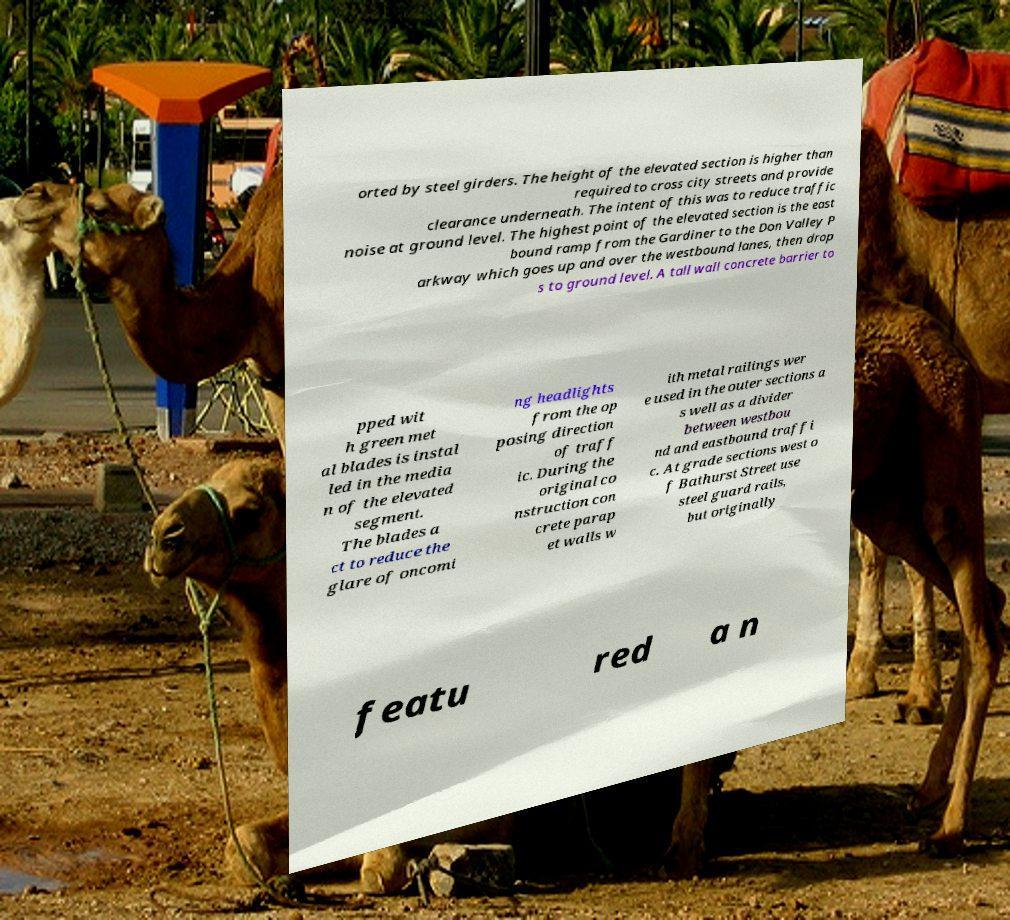For documentation purposes, I need the text within this image transcribed. Could you provide that? orted by steel girders. The height of the elevated section is higher than required to cross city streets and provide clearance underneath. The intent of this was to reduce traffic noise at ground level. The highest point of the elevated section is the east bound ramp from the Gardiner to the Don Valley P arkway which goes up and over the westbound lanes, then drop s to ground level. A tall wall concrete barrier to pped wit h green met al blades is instal led in the media n of the elevated segment. The blades a ct to reduce the glare of oncomi ng headlights from the op posing direction of traff ic. During the original co nstruction con crete parap et walls w ith metal railings wer e used in the outer sections a s well as a divider between westbou nd and eastbound traffi c. At grade sections west o f Bathurst Street use steel guard rails, but originally featu red a n 